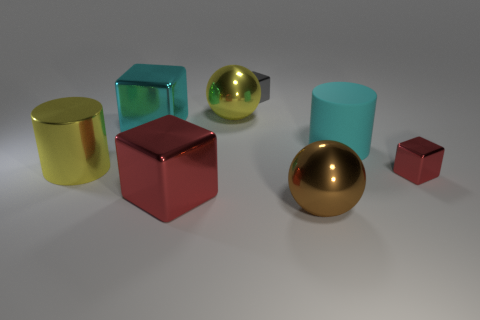Add 1 large yellow metal cylinders. How many objects exist? 9 Subtract all balls. How many objects are left? 6 Subtract all tiny gray cubes. Subtract all large brown things. How many objects are left? 6 Add 1 balls. How many balls are left? 3 Add 6 large red matte objects. How many large red matte objects exist? 6 Subtract 0 green cylinders. How many objects are left? 8 